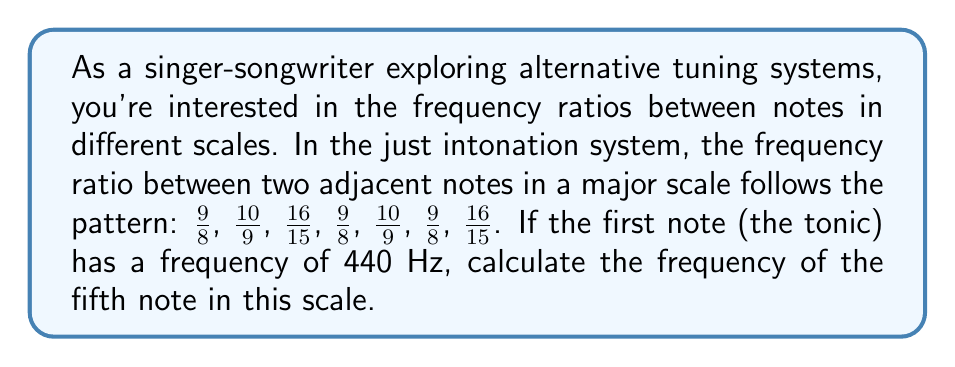Give your solution to this math problem. Let's approach this step-by-step:

1) First, we need to multiply the frequency of the tonic by each ratio in sequence until we reach the fifth note.

2) The tonic frequency is 440 Hz.

3) For the second note:
   $440 \cdot \frac{9}{8} = 495$ Hz

4) For the third note:
   $495 \cdot \frac{10}{9} = 550$ Hz

5) For the fourth note:
   $550 \cdot \frac{16}{15} = 586.\overline{6}$ Hz

6) For the fifth note:
   $586.\overline{6} \cdot \frac{9}{8} = 660$ Hz

7) We can verify this by calculating the overall ratio from the tonic to the fifth note:

   $$\frac{9}{8} \cdot \frac{10}{9} \cdot \frac{16}{15} \cdot \frac{9}{8} = \frac{3}{2}$$

8) Indeed, $440 \cdot \frac{3}{2} = 660$ Hz, which confirms our step-by-step calculation.
Answer: 660 Hz 